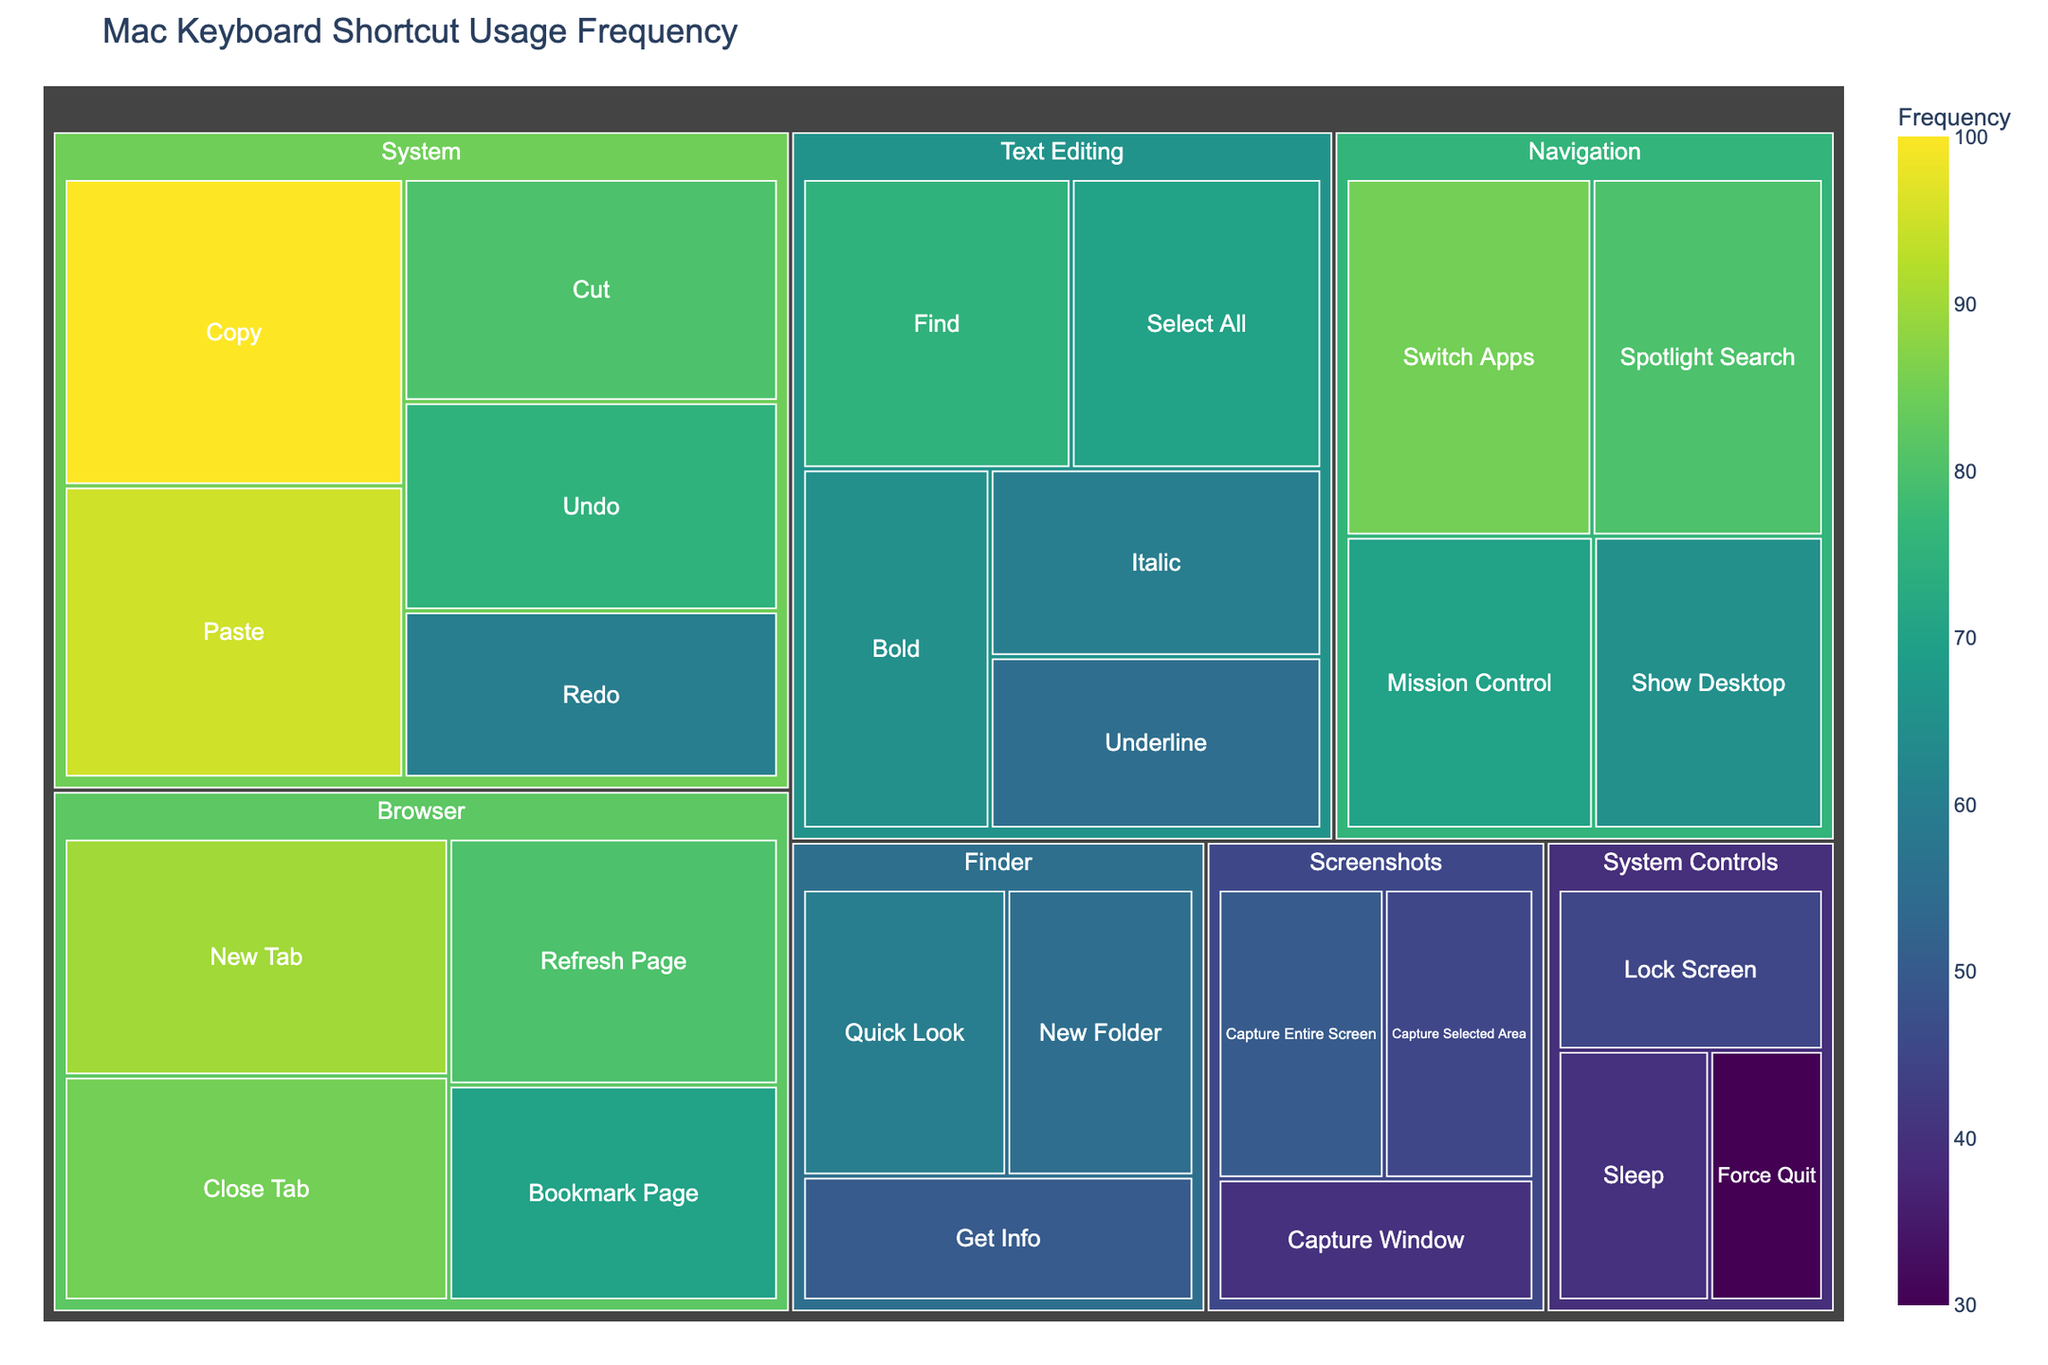What is the title of the treemap? The title of a chart is usually positioned at the top, providing an overview of what the chart represents. In this case, the title is "Mac Keyboard Shortcut Usage Frequency".
Answer: Mac Keyboard Shortcut Usage Frequency Which category has the highest frequency? By observing the size and color (with darker colors indicating higher frequency) of the rectangles, the category with the highest frequency subcategories is "System".
Answer: System How many subcategories are there in the "Browser" category? To count the subcategories, look for the labeled rectangles under the "Browser" category. Here, we see "New Tab", "Close Tab", "Refresh Page", and "Bookmark Page".
Answer: 4 What is the frequency of the "Copy" shortcut in the "System" category? By hovering over or reading the label of the "Copy" subcategory under "System", the frequency can be identified as 100.
Answer: 100 Which subcategory within "Screenshots" has the lowest frequency? Compare the frequencies of "Capture Entire Screen", "Capture Selected Area", and "Capture Window" within "Screenshots". The lowest frequency is for "Capture Window" with a value of 40.
Answer: Capture Window What is the total frequency of the "Navigation" category? Sum the frequencies of all subcategories within "Navigation": "Switch Apps" (85), "Mission Control" (70), "Show Desktop" (65), and "Spotlight Search" (80); the total is 85 + 70 + 65 + 80 = 300.
Answer: 300 Which category has a subcategory with exactly 70 in frequency? Look at each category and identify any subcategory with a frequency of 70. From the data, "Navigation" (Spotlight Search) and "Browser" (Bookmark Page) match.
Answer: Navigation and Browser How does the frequency of "New Folder" in the "Finder" category compare to "Sleep" in "System Controls"? Compare the frequencies of "New Folder" under "Finder" (55) and "Sleep" under "System Controls" (40). 55 is greater than 40.
Answer: Finder's New Folder has a higher frequency Which subcategory in the "System Controls" category has the highest frequency? To find the highest frequency, compare the values within the "System Controls" category: "Sleep" (40), "Lock Screen" (45), and "Force Quit" (30). The highest frequency is 45 for "Lock Screen".
Answer: Lock Screen 